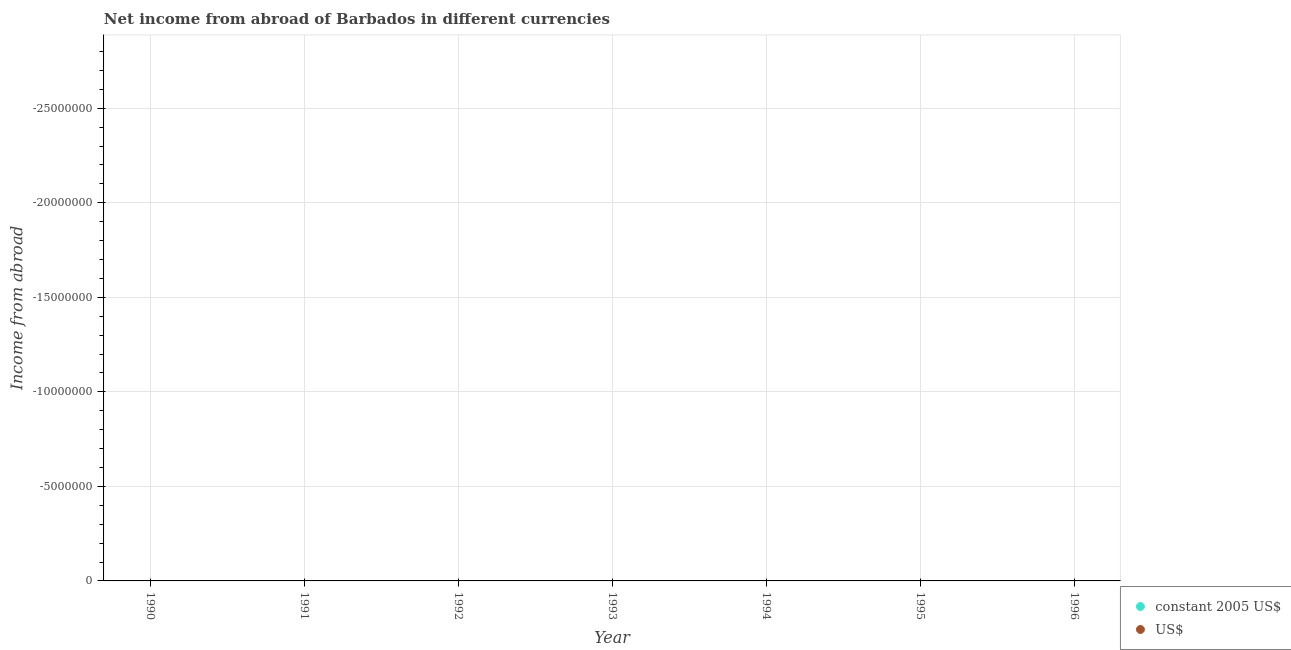How many different coloured dotlines are there?
Offer a terse response. 0. What is the total income from abroad in constant 2005 us$ in the graph?
Offer a terse response. 0. What is the difference between the income from abroad in us$ in 1990 and the income from abroad in constant 2005 us$ in 1993?
Offer a terse response. 0. What is the average income from abroad in constant 2005 us$ per year?
Keep it short and to the point. 0. In how many years, is the income from abroad in us$ greater than the average income from abroad in us$ taken over all years?
Keep it short and to the point. 0. Is the income from abroad in us$ strictly greater than the income from abroad in constant 2005 us$ over the years?
Ensure brevity in your answer.  Yes. Is the income from abroad in constant 2005 us$ strictly less than the income from abroad in us$ over the years?
Keep it short and to the point. Yes. How many years are there in the graph?
Your answer should be compact. 7. Are the values on the major ticks of Y-axis written in scientific E-notation?
Offer a terse response. No. Does the graph contain any zero values?
Offer a terse response. Yes. What is the title of the graph?
Give a very brief answer. Net income from abroad of Barbados in different currencies. Does "Lower secondary education" appear as one of the legend labels in the graph?
Your answer should be very brief. No. What is the label or title of the X-axis?
Make the answer very short. Year. What is the label or title of the Y-axis?
Your answer should be compact. Income from abroad. What is the Income from abroad of US$ in 1990?
Your answer should be compact. 0. What is the Income from abroad in US$ in 1991?
Provide a short and direct response. 0. What is the Income from abroad of constant 2005 US$ in 1992?
Offer a terse response. 0. What is the Income from abroad of constant 2005 US$ in 1993?
Your response must be concise. 0. What is the Income from abroad in US$ in 1993?
Keep it short and to the point. 0. What is the Income from abroad of US$ in 1996?
Your answer should be compact. 0. 